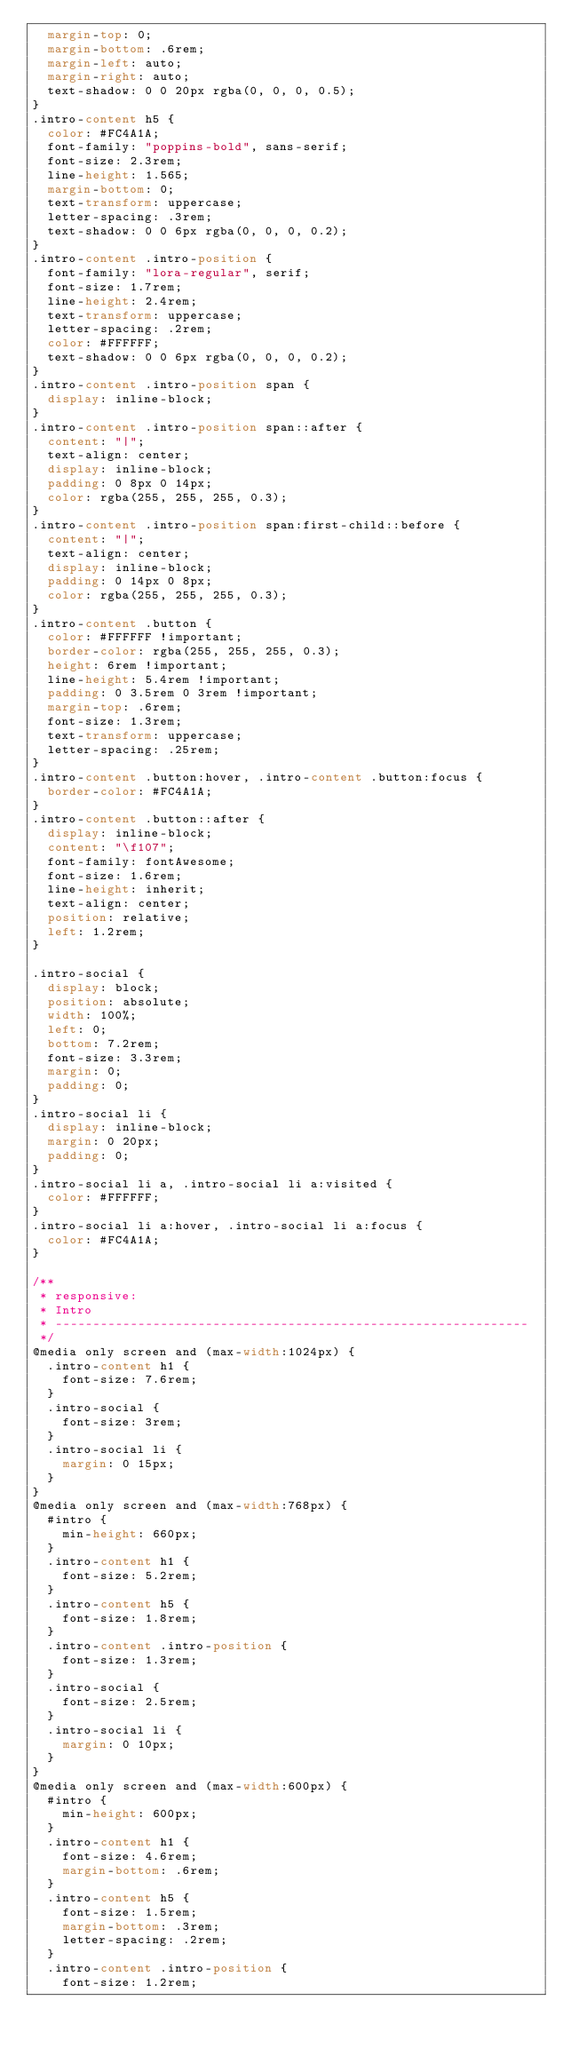Convert code to text. <code><loc_0><loc_0><loc_500><loc_500><_CSS_>	margin-top: 0;
	margin-bottom: .6rem;
	margin-left: auto;
	margin-right: auto;
	text-shadow: 0 0 20px rgba(0, 0, 0, 0.5);
}
.intro-content h5 {
	color: #FC4A1A;
	font-family: "poppins-bold", sans-serif;
	font-size: 2.3rem;
	line-height: 1.565;
	margin-bottom: 0;
	text-transform: uppercase;
	letter-spacing: .3rem;
	text-shadow: 0 0 6px rgba(0, 0, 0, 0.2);
}
.intro-content .intro-position {
	font-family: "lora-regular", serif;
	font-size: 1.7rem;
	line-height: 2.4rem;
	text-transform: uppercase;
	letter-spacing: .2rem;
	color: #FFFFFF;
	text-shadow: 0 0 6px rgba(0, 0, 0, 0.2);
}
.intro-content .intro-position span {
	display: inline-block;
}
.intro-content .intro-position span::after {
	content: "|";
	text-align: center;
	display: inline-block;
	padding: 0 8px 0 14px;
	color: rgba(255, 255, 255, 0.3);
}
.intro-content .intro-position span:first-child::before {
	content: "|";
	text-align: center;
	display: inline-block;
	padding: 0 14px 0 8px;
	color: rgba(255, 255, 255, 0.3);
}
.intro-content .button {
	color: #FFFFFF !important;
	border-color: rgba(255, 255, 255, 0.3);
	height: 6rem !important;
	line-height: 5.4rem !important;
	padding: 0 3.5rem 0 3rem !important;
	margin-top: .6rem;
	font-size: 1.3rem;
	text-transform: uppercase;
	letter-spacing: .25rem;
}
.intro-content .button:hover, .intro-content .button:focus {
	border-color: #FC4A1A;
}
.intro-content .button::after {
	display: inline-block;
	content: "\f107";
	font-family: fontAwesome;
	font-size: 1.6rem;
	line-height: inherit;
	text-align: center;
	position: relative;
	left: 1.2rem;
}

.intro-social {
	display: block;
	position: absolute;
	width: 100%;
	left: 0;
	bottom: 7.2rem;
	font-size: 3.3rem;
	margin: 0;
	padding: 0;
}
.intro-social li {
	display: inline-block;
	margin: 0 20px;
	padding: 0;
}
.intro-social li a, .intro-social li a:visited {
	color: #FFFFFF;
}
.intro-social li a:hover, .intro-social li a:focus {
	color: #FC4A1A;
}

/**
 * responsive:
 * Intro
 * --------------------------------------------------------------- 
 */
@media only screen and (max-width:1024px) {
	.intro-content h1 {
		font-size: 7.6rem;
	}
	.intro-social {
		font-size: 3rem;
	}
	.intro-social li {
		margin: 0 15px;
	}
}
@media only screen and (max-width:768px) {
	#intro {
		min-height: 660px;
	}
	.intro-content h1 {
		font-size: 5.2rem;
	}
	.intro-content h5 {
		font-size: 1.8rem;
	}
	.intro-content .intro-position {
		font-size: 1.3rem;
	}
	.intro-social {
		font-size: 2.5rem;
	}
	.intro-social li {
		margin: 0 10px;
	}
}
@media only screen and (max-width:600px) {
	#intro {
		min-height: 600px;
	}
	.intro-content h1 {
		font-size: 4.6rem;
		margin-bottom: .6rem;
	}
	.intro-content h5 {
		font-size: 1.5rem;
		margin-bottom: .3rem;
		letter-spacing: .2rem;
	}
	.intro-content .intro-position {
		font-size: 1.2rem;</code> 